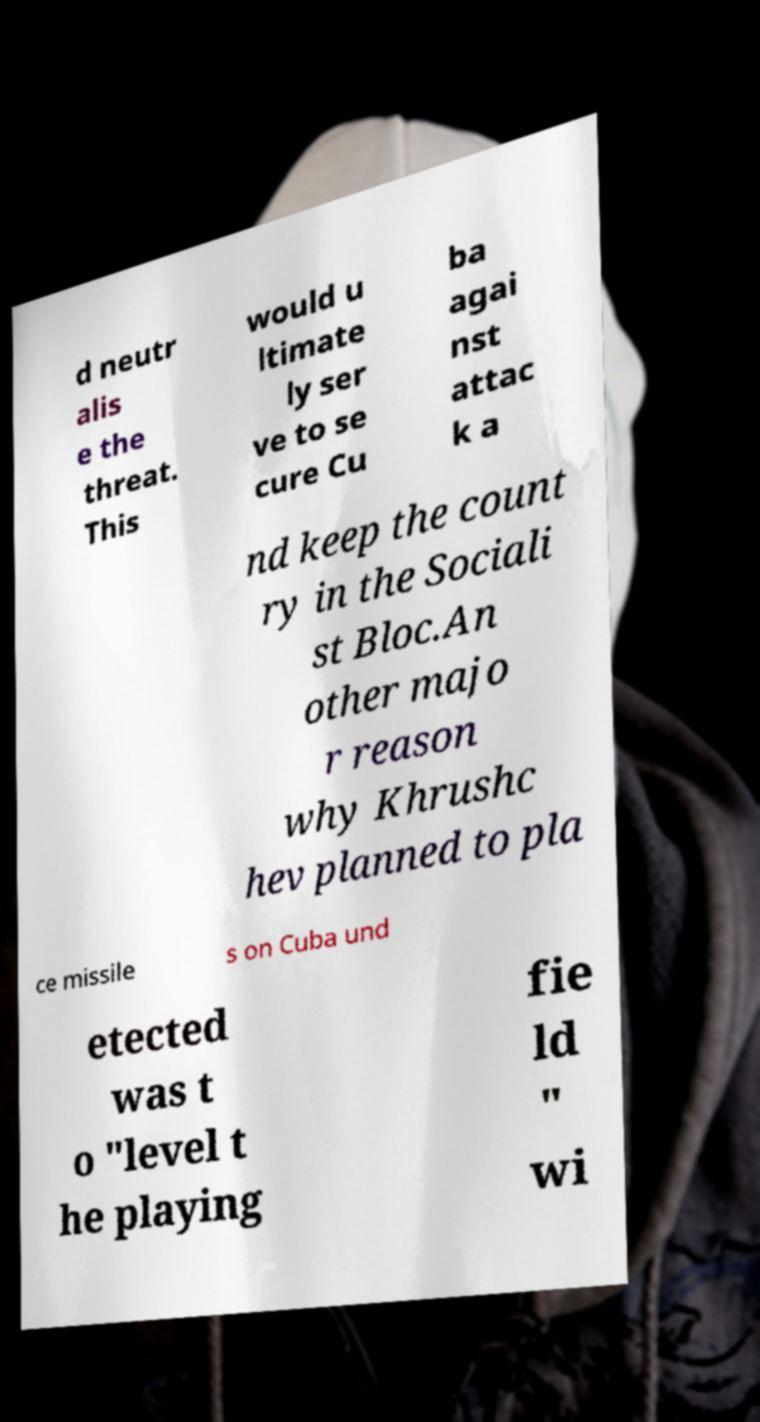There's text embedded in this image that I need extracted. Can you transcribe it verbatim? d neutr alis e the threat. This would u ltimate ly ser ve to se cure Cu ba agai nst attac k a nd keep the count ry in the Sociali st Bloc.An other majo r reason why Khrushc hev planned to pla ce missile s on Cuba und etected was t o "level t he playing fie ld " wi 